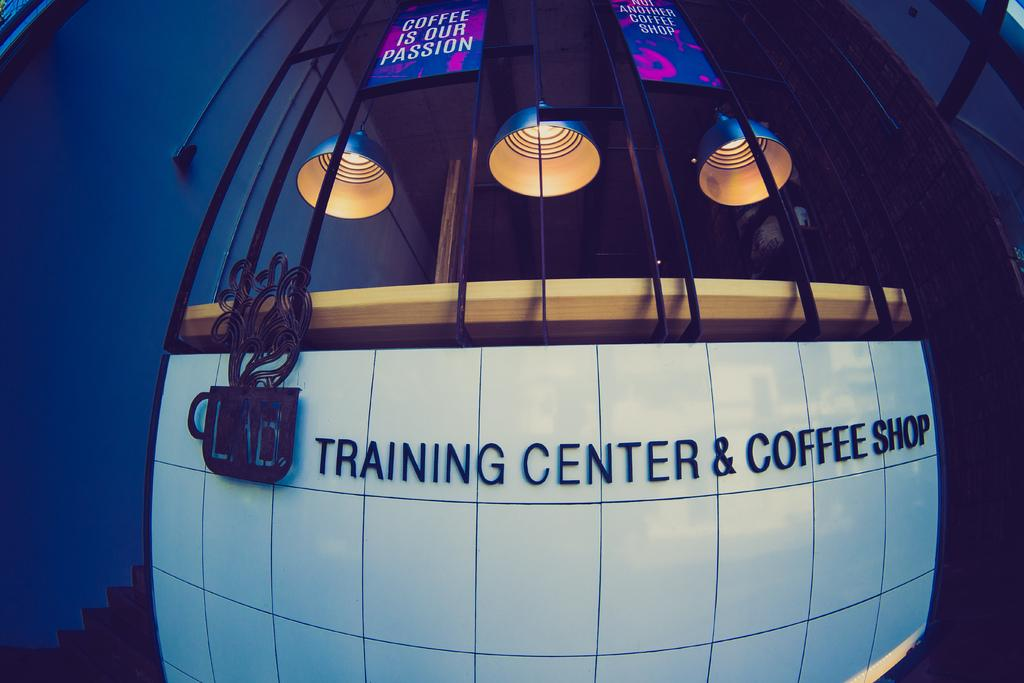<image>
Offer a succinct explanation of the picture presented. a building that has the words training center on it 